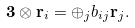Convert formula to latex. <formula><loc_0><loc_0><loc_500><loc_500>\mathbf 3 \otimes \mathbf r _ { i } = \oplus _ { j } b _ { i j } \mathbf r _ { j } .</formula> 